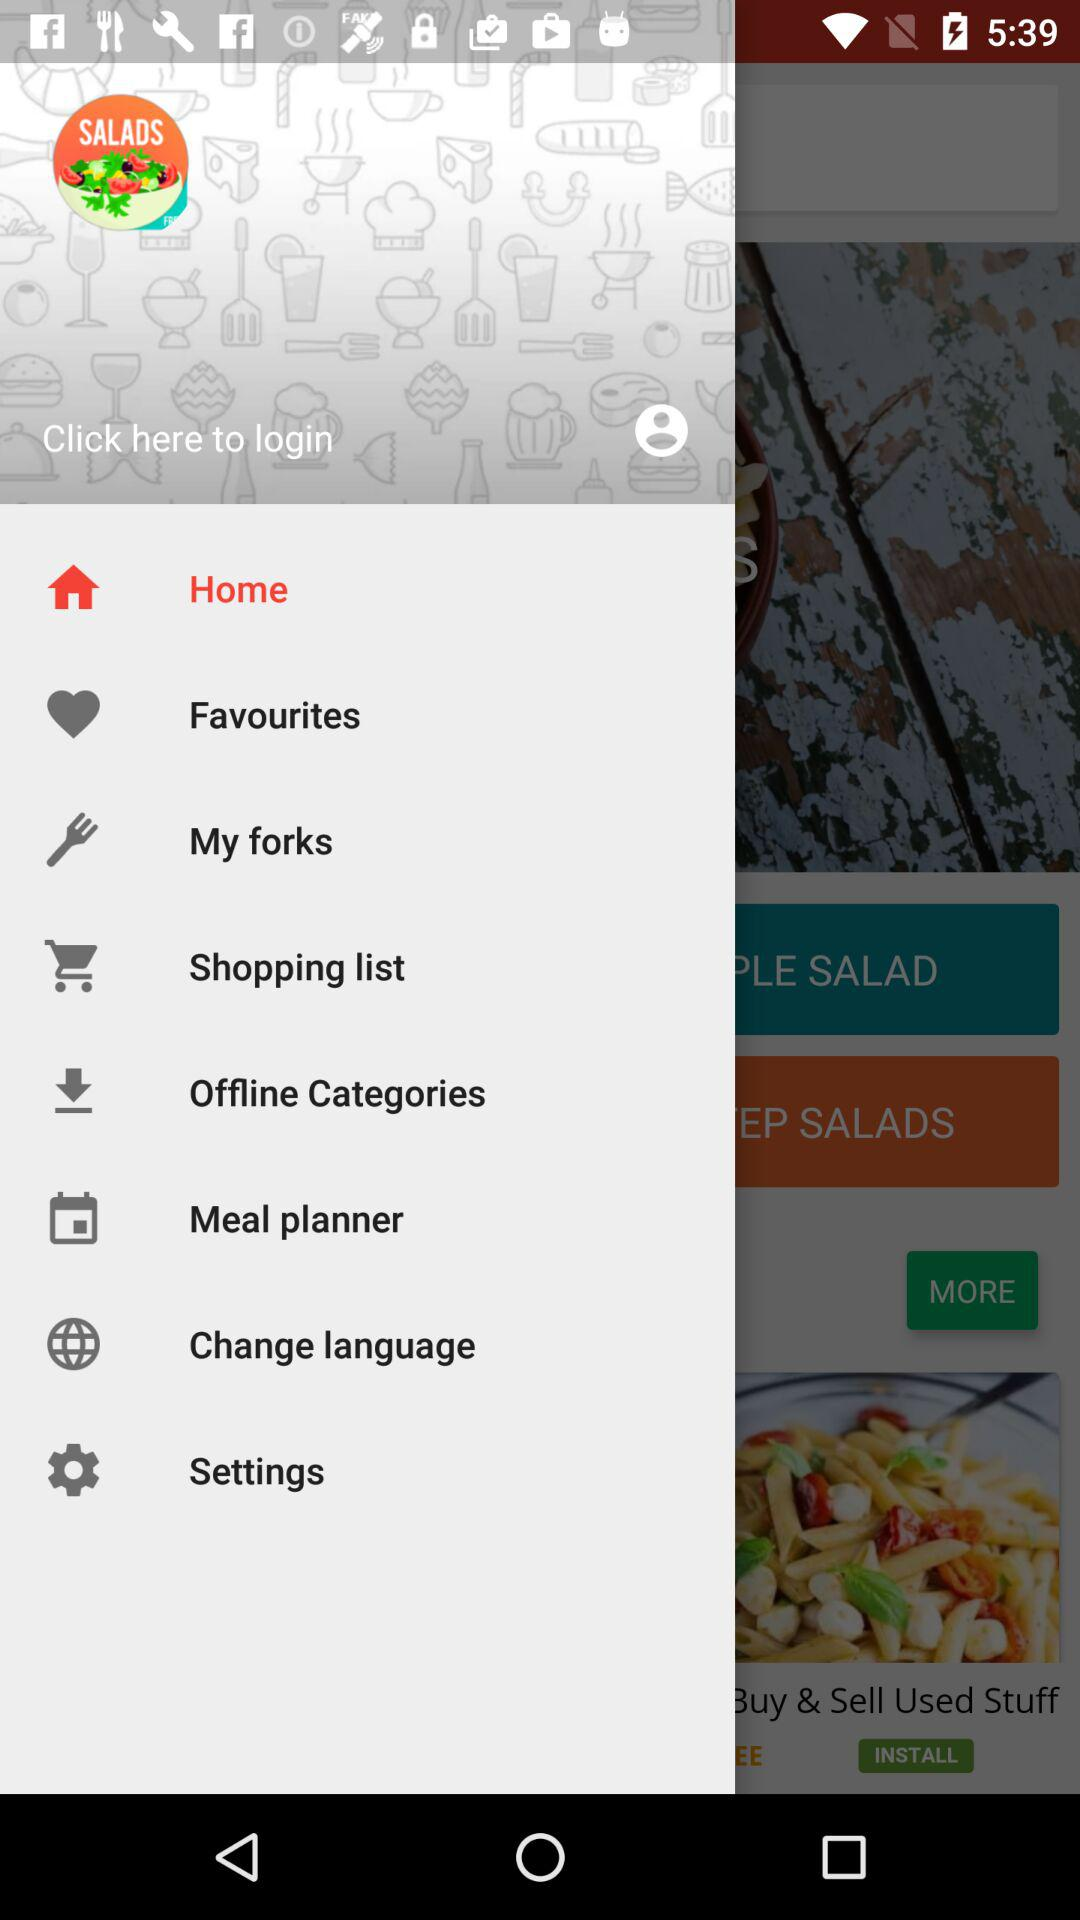Which item has been selected? The selected item is "Home". 